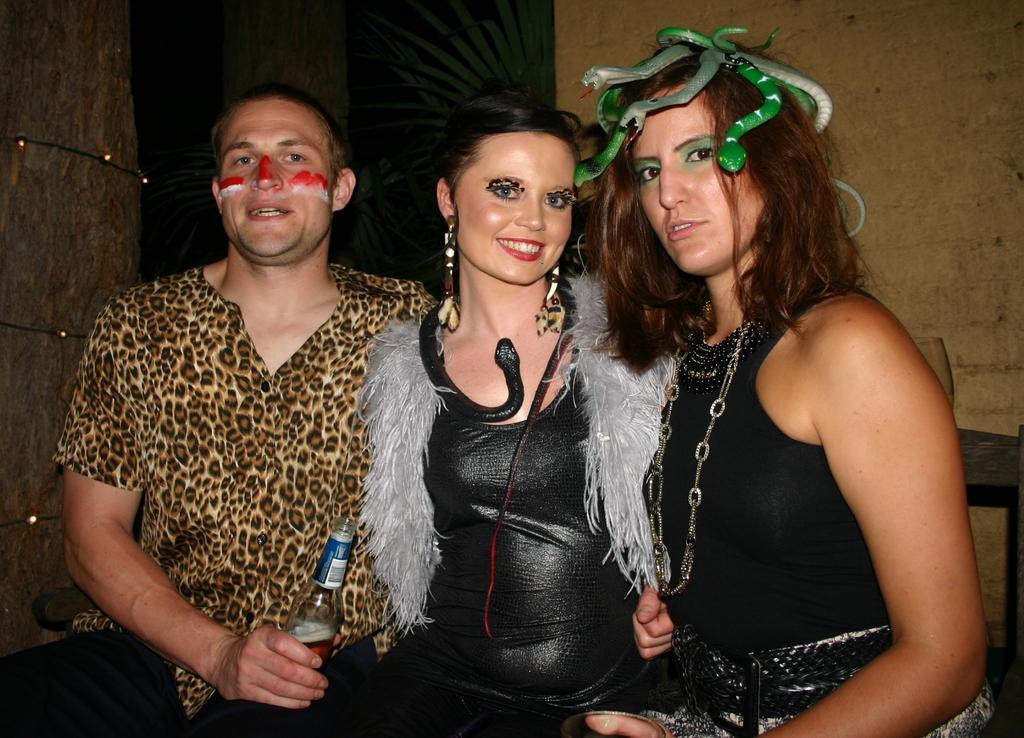In one or two sentences, can you explain what this image depicts? In this image we can see this person wearing shirt is holding a bottle with a label on it. Here we can see these two women wearing black dresses are smiling. The background of the image is dark where we can see the wall. 